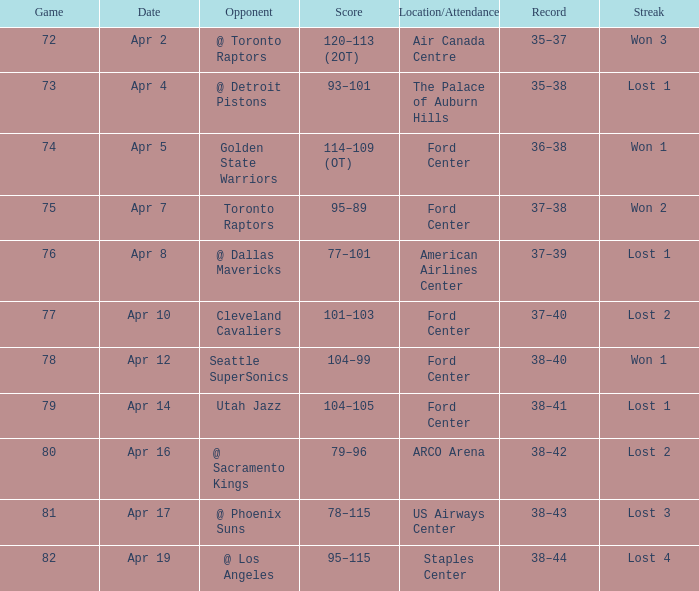What was the location when the opponent was Seattle Supersonics? Ford Center. 